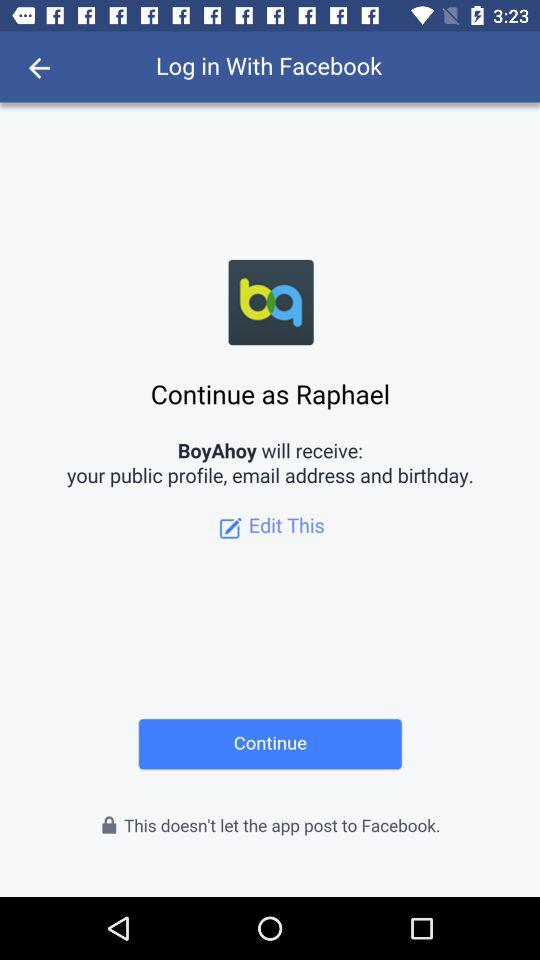What application will receive my public profile, email address and birthday? The name of the application is "BoyAhoy". 